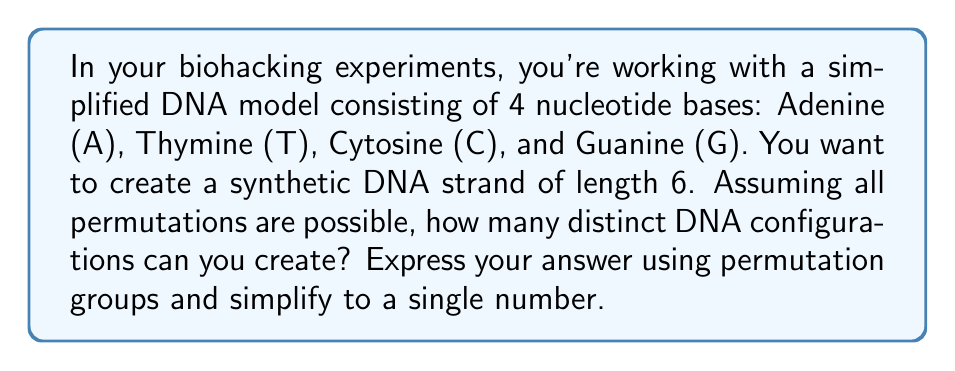Solve this math problem. To solve this problem, we'll use concepts from permutation groups in Group theory:

1) First, we need to understand that this is a problem of permutations with repetition. We have 4 choices (A, T, C, G) for each of the 6 positions in the DNA strand.

2) In group theory, this can be represented as the direct product of 6 cyclic groups of order 4:

   $$G = C_4 \times C_4 \times C_4 \times C_4 \times C_4 \times C_4$$

   Where $C_4$ represents a cyclic group of order 4 (our 4 nucleotide bases).

3) The order of a direct product of groups is the product of the orders of the individual groups. So, the order of our group G is:

   $$|G| = |C_4|^6 = 4^6$$

4) The order of the group represents the number of elements in the group, which in this case corresponds to the number of distinct DNA configurations.

5) Calculate $4^6$:
   
   $$4^6 = 4 \times 4 \times 4 \times 4 \times 4 \times 4 = 4096$$

Therefore, there are 4096 distinct DNA configurations possible in this simplified model.
Answer: 4096 